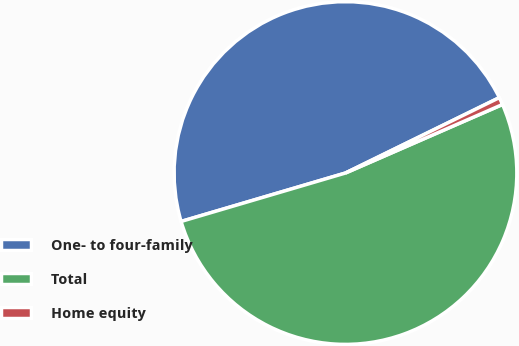Convert chart to OTSL. <chart><loc_0><loc_0><loc_500><loc_500><pie_chart><fcel>One- to four-family<fcel>Total<fcel>Home equity<nl><fcel>47.31%<fcel>51.99%<fcel>0.7%<nl></chart> 